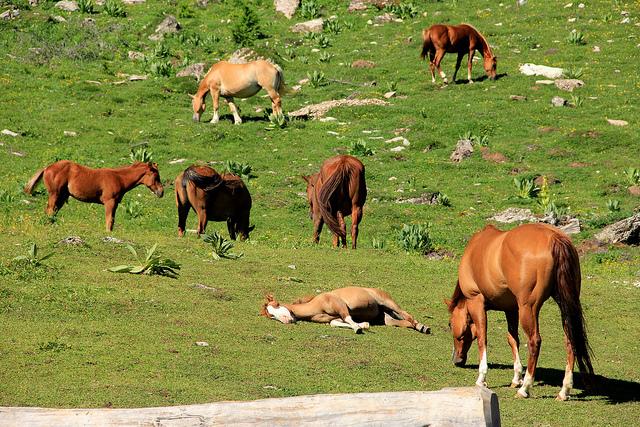How many horses?
Write a very short answer. 7. Where is the lightest colored horse at?
Answer briefly. Back. Is one of the horses sleeping?
Answer briefly. Yes. 